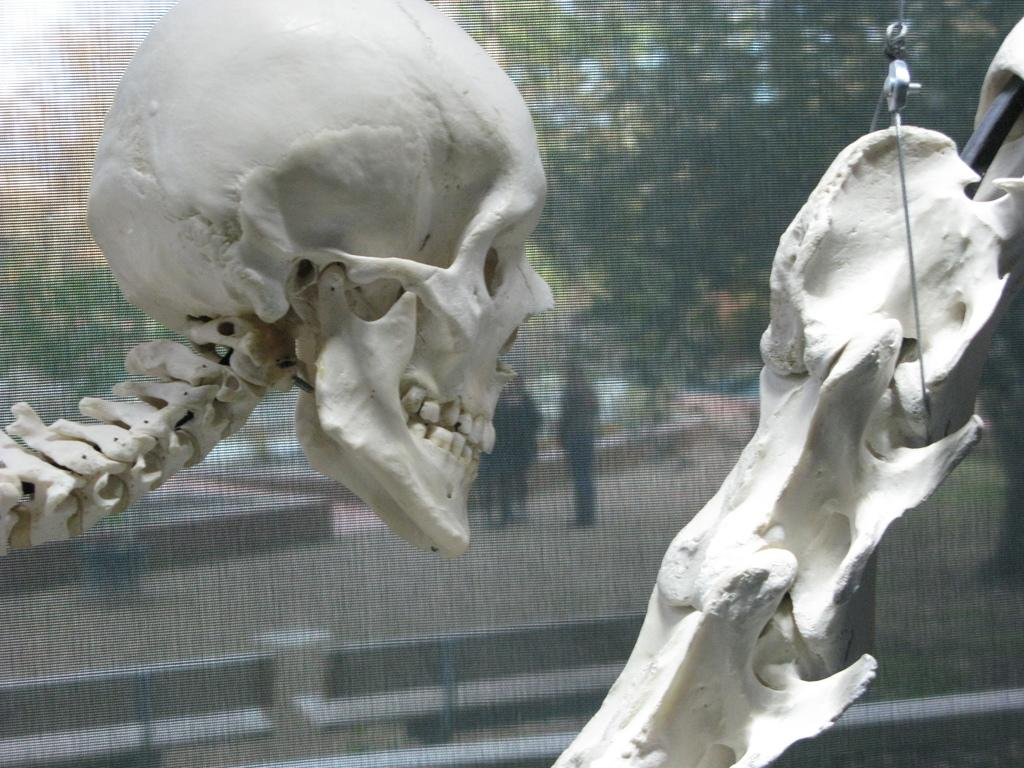What is the main subject of the image? There is a skeleton in the image. What can be seen in the background of the image? There is a glass in the background of the image, through which people, trees, and the sky are visible. What type of skin can be seen on the skeleton in the image? There is no skin present on the skeleton in the image, as it is a representation of the bones without any soft tissue. How many books are visible on the shelves behind the skeleton in the image? There are no bookshelves or books visible in the image; it only features a skeleton and a glass with views of people, trees, and the sky. 